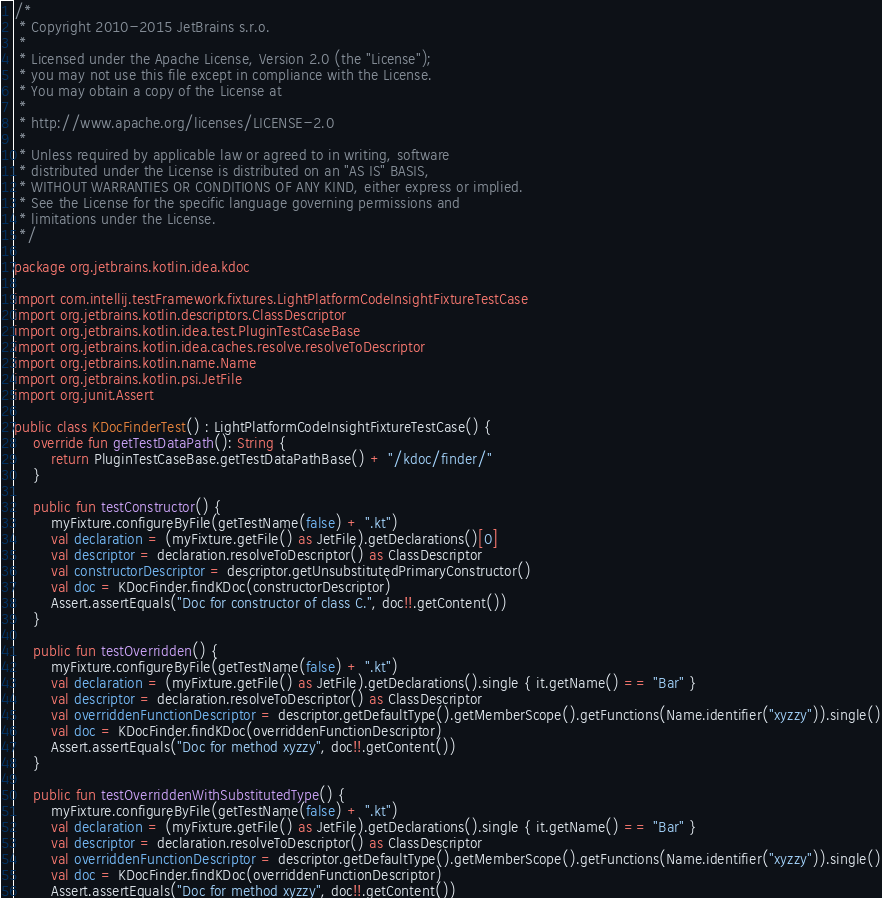<code> <loc_0><loc_0><loc_500><loc_500><_Kotlin_>/*
 * Copyright 2010-2015 JetBrains s.r.o.
 *
 * Licensed under the Apache License, Version 2.0 (the "License");
 * you may not use this file except in compliance with the License.
 * You may obtain a copy of the License at
 *
 * http://www.apache.org/licenses/LICENSE-2.0
 *
 * Unless required by applicable law or agreed to in writing, software
 * distributed under the License is distributed on an "AS IS" BASIS,
 * WITHOUT WARRANTIES OR CONDITIONS OF ANY KIND, either express or implied.
 * See the License for the specific language governing permissions and
 * limitations under the License.
 */

package org.jetbrains.kotlin.idea.kdoc

import com.intellij.testFramework.fixtures.LightPlatformCodeInsightFixtureTestCase
import org.jetbrains.kotlin.descriptors.ClassDescriptor
import org.jetbrains.kotlin.idea.test.PluginTestCaseBase
import org.jetbrains.kotlin.idea.caches.resolve.resolveToDescriptor
import org.jetbrains.kotlin.name.Name
import org.jetbrains.kotlin.psi.JetFile
import org.junit.Assert

public class KDocFinderTest() : LightPlatformCodeInsightFixtureTestCase() {
    override fun getTestDataPath(): String {
        return PluginTestCaseBase.getTestDataPathBase() + "/kdoc/finder/"
    }

    public fun testConstructor() {
        myFixture.configureByFile(getTestName(false) + ".kt")
        val declaration = (myFixture.getFile() as JetFile).getDeclarations()[0]
        val descriptor = declaration.resolveToDescriptor() as ClassDescriptor
        val constructorDescriptor = descriptor.getUnsubstitutedPrimaryConstructor()
        val doc = KDocFinder.findKDoc(constructorDescriptor)
        Assert.assertEquals("Doc for constructor of class C.", doc!!.getContent())
    }

    public fun testOverridden() {
        myFixture.configureByFile(getTestName(false) + ".kt")
        val declaration = (myFixture.getFile() as JetFile).getDeclarations().single { it.getName() == "Bar" }
        val descriptor = declaration.resolveToDescriptor() as ClassDescriptor
        val overriddenFunctionDescriptor = descriptor.getDefaultType().getMemberScope().getFunctions(Name.identifier("xyzzy")).single()
        val doc = KDocFinder.findKDoc(overriddenFunctionDescriptor)
        Assert.assertEquals("Doc for method xyzzy", doc!!.getContent())
    }

    public fun testOverriddenWithSubstitutedType() {
        myFixture.configureByFile(getTestName(false) + ".kt")
        val declaration = (myFixture.getFile() as JetFile).getDeclarations().single { it.getName() == "Bar" }
        val descriptor = declaration.resolveToDescriptor() as ClassDescriptor
        val overriddenFunctionDescriptor = descriptor.getDefaultType().getMemberScope().getFunctions(Name.identifier("xyzzy")).single()
        val doc = KDocFinder.findKDoc(overriddenFunctionDescriptor)
        Assert.assertEquals("Doc for method xyzzy", doc!!.getContent())</code> 